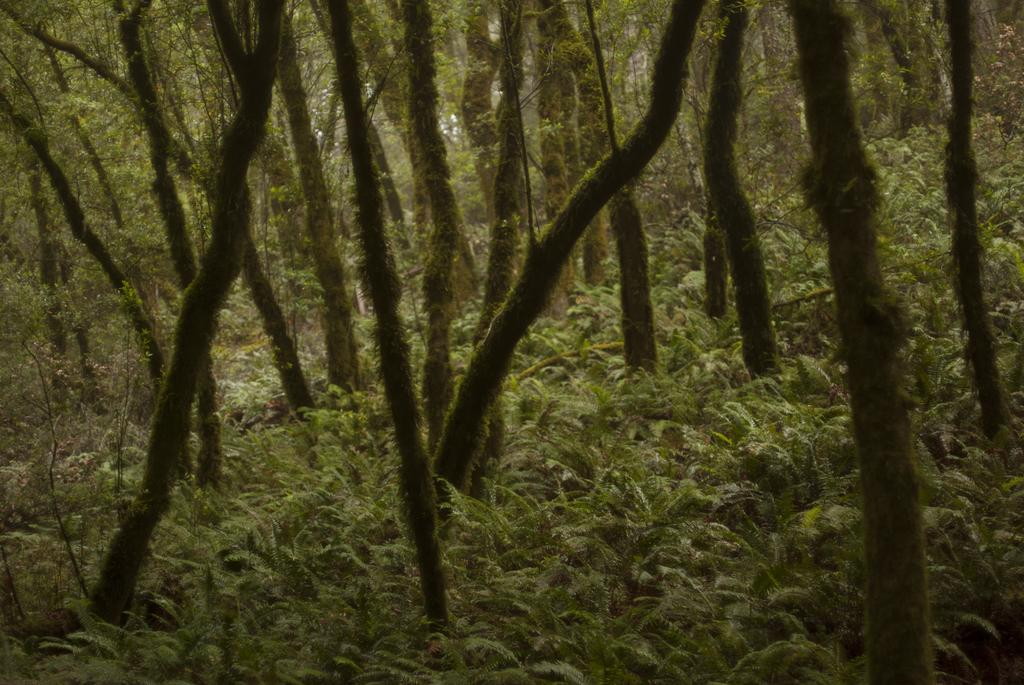What type of vegetation can be seen in the image? There are trees and plants in the image. Can you describe the natural elements present in the image? The image features trees and plants, which are both types of vegetation. What is the tendency of the dirt to form patterns in the image? There is no dirt present in the image, so it is not possible to determine any tendencies related to dirt. 